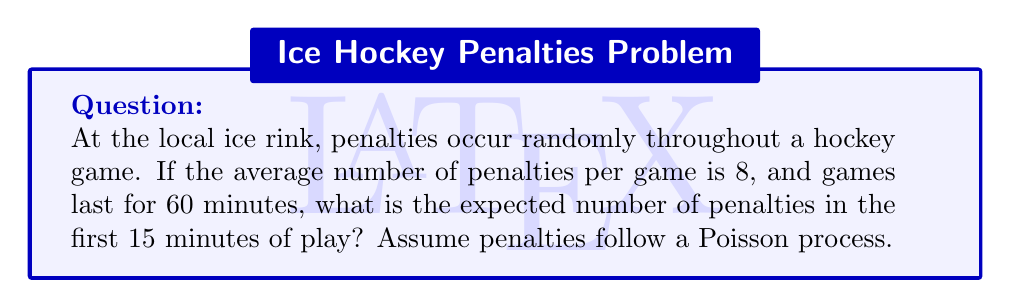Could you help me with this problem? Let's approach this step-by-step:

1) In a Poisson process, events (in this case, penalties) occur independently at a constant average rate.

2) We're given that the average number of penalties per game is 8, and a game lasts 60 minutes. Let's call the rate parameter λ (lambda).

3) To find λ, we divide the average number of events by the total time:
   $$ \lambda = \frac{8 \text{ penalties}}{60 \text{ minutes}} = \frac{2}{15} \text{ penalties per minute} $$

4) Now, we want to find the expected number of penalties in 15 minutes. In a Poisson process, the expected number of events in any time interval is proportional to the length of the interval.

5) Let E(X) be the expected number of penalties in 15 minutes. We can calculate this as:
   $$ E(X) = \lambda \cdot t = \frac{2}{15} \cdot 15 = 2 $$

Therefore, the expected number of penalties in the first 15 minutes of play is 2.
Answer: 2 penalties 